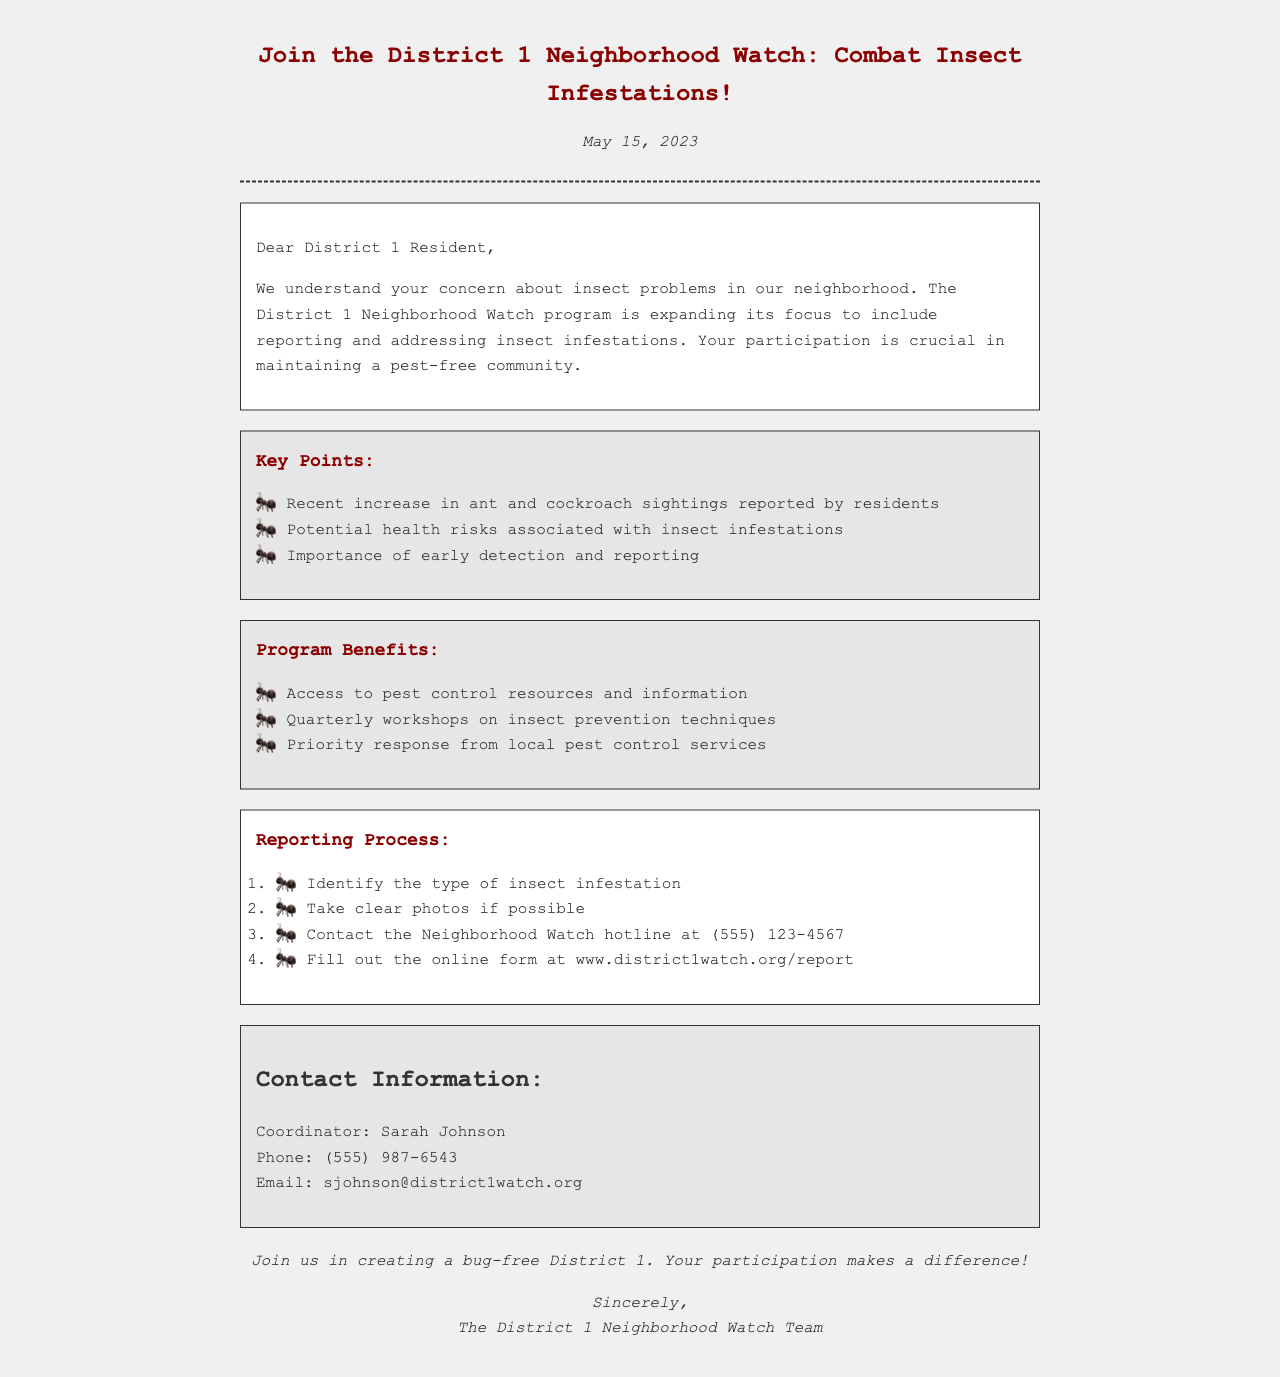What is the date of the fax? The date is mentioned at the top of the document, specifically in the introduction section.
Answer: May 15, 2023 Who is the coordinator for the Neighborhood Watch program? The coordinator's name is listed in the contact information section.
Answer: Sarah Johnson What is the Neighborhood Watch hotline number? The hotline number is provided in the reporting process section for residents to contact regarding infestations.
Answer: (555) 123-4567 What are the first two steps in the reporting process? The first two steps are outlined in the sequence of actions residents should take when reporting infestations.
Answer: Identify the type of insect infestation; Take clear photos if possible What is one benefit of joining the Neighborhood Watch? Benefits are listed under the program benefits section that outlines what participants will gain by joining.
Answer: Access to pest control resources and information What type of pests have recently been seen in District 1? The key points section highlights specific pest problems that the program is addressing.
Answer: Ant and cockroach What is the purpose of the Neighborhood Watch program related to insects? The introduction outlines the main goal of the program as it expands its focus.
Answer: Reporting and addressing insect infestations How often will workshops on insect prevention techniques be held? The frequency of workshops is mentioned in the program benefits section.
Answer: Quarterly 